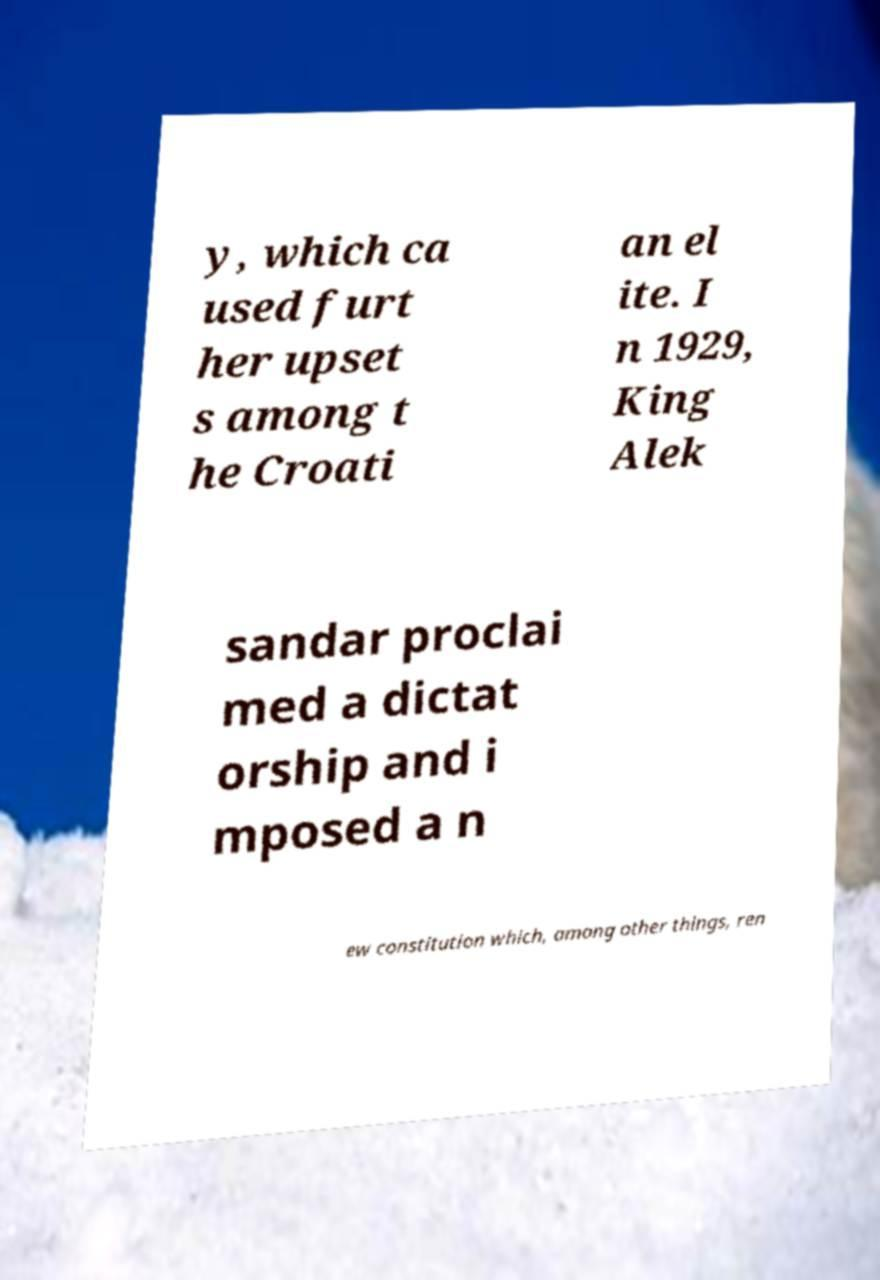Could you extract and type out the text from this image? y, which ca used furt her upset s among t he Croati an el ite. I n 1929, King Alek sandar proclai med a dictat orship and i mposed a n ew constitution which, among other things, ren 